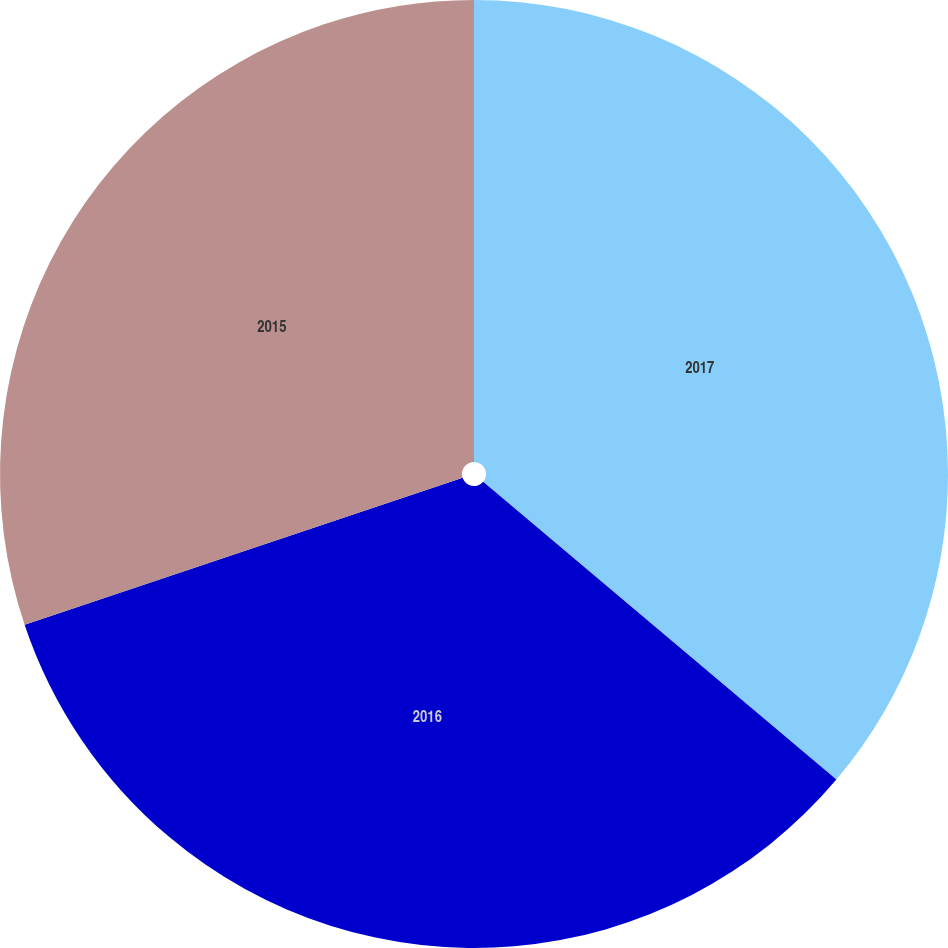Convert chart. <chart><loc_0><loc_0><loc_500><loc_500><pie_chart><fcel>2017<fcel>2016<fcel>2015<nl><fcel>36.15%<fcel>33.7%<fcel>30.15%<nl></chart> 